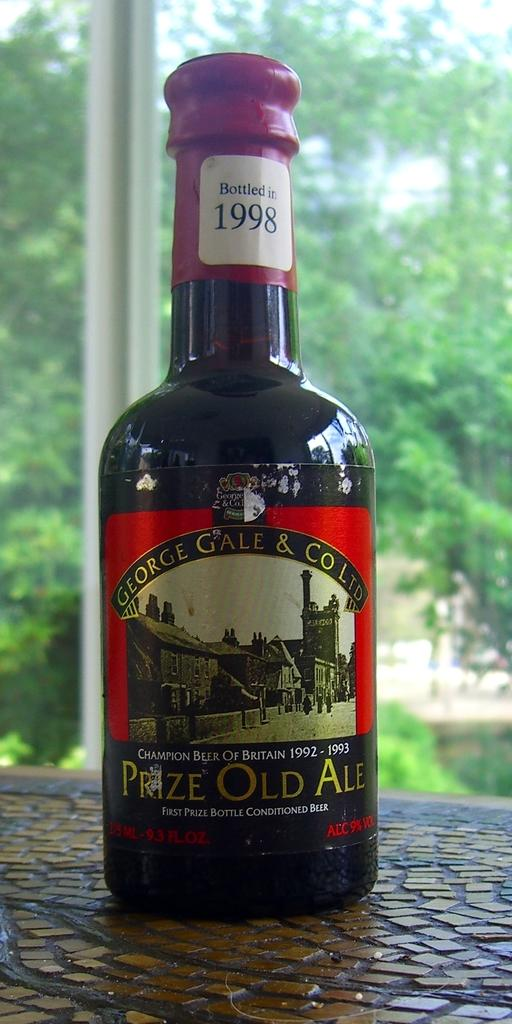<image>
Summarize the visual content of the image. Bottle of beer with a label which syas "Prize Old Ale". 